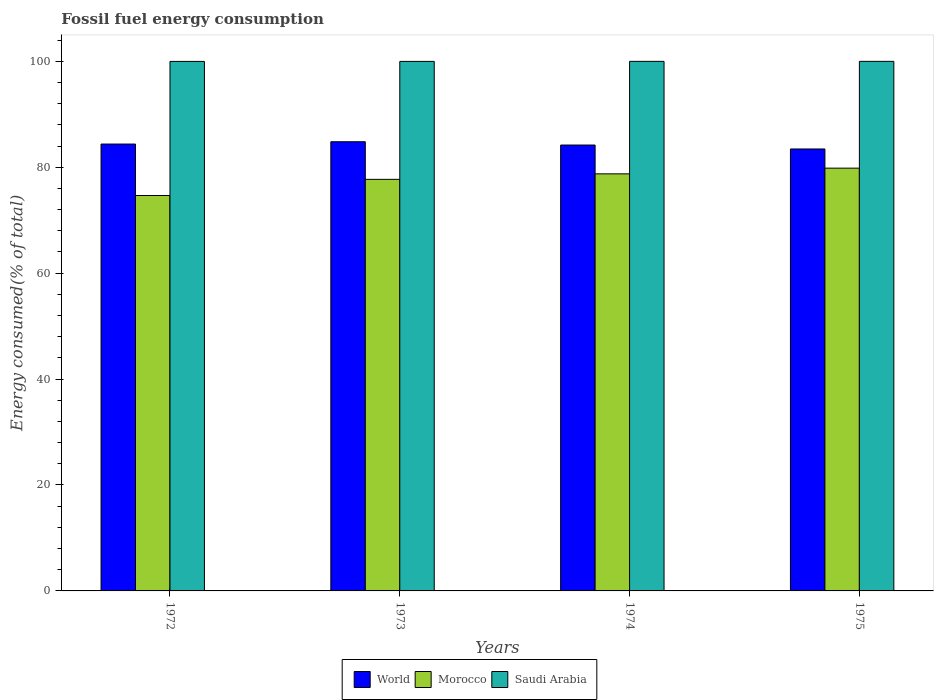Are the number of bars on each tick of the X-axis equal?
Make the answer very short. Yes. What is the label of the 1st group of bars from the left?
Offer a terse response. 1972. What is the percentage of energy consumed in World in 1975?
Your response must be concise. 83.44. Across all years, what is the maximum percentage of energy consumed in Saudi Arabia?
Keep it short and to the point. 99.99. Across all years, what is the minimum percentage of energy consumed in Saudi Arabia?
Ensure brevity in your answer.  99.98. In which year was the percentage of energy consumed in Saudi Arabia maximum?
Make the answer very short. 1975. What is the total percentage of energy consumed in Morocco in the graph?
Make the answer very short. 310.94. What is the difference between the percentage of energy consumed in Morocco in 1973 and that in 1975?
Your answer should be very brief. -2.12. What is the difference between the percentage of energy consumed in World in 1973 and the percentage of energy consumed in Saudi Arabia in 1972?
Provide a short and direct response. -15.17. What is the average percentage of energy consumed in World per year?
Provide a short and direct response. 84.2. In the year 1973, what is the difference between the percentage of energy consumed in World and percentage of energy consumed in Saudi Arabia?
Offer a terse response. -15.17. In how many years, is the percentage of energy consumed in Morocco greater than 76 %?
Offer a very short reply. 3. What is the ratio of the percentage of energy consumed in Saudi Arabia in 1972 to that in 1974?
Offer a terse response. 1. Is the percentage of energy consumed in Saudi Arabia in 1972 less than that in 1975?
Your answer should be compact. Yes. What is the difference between the highest and the second highest percentage of energy consumed in World?
Your answer should be very brief. 0.44. What is the difference between the highest and the lowest percentage of energy consumed in World?
Give a very brief answer. 1.37. What does the 3rd bar from the left in 1975 represents?
Keep it short and to the point. Saudi Arabia. What does the 1st bar from the right in 1973 represents?
Ensure brevity in your answer.  Saudi Arabia. Are all the bars in the graph horizontal?
Your response must be concise. No. How many years are there in the graph?
Offer a terse response. 4. Does the graph contain any zero values?
Your answer should be very brief. No. Where does the legend appear in the graph?
Your response must be concise. Bottom center. How are the legend labels stacked?
Offer a terse response. Horizontal. What is the title of the graph?
Provide a short and direct response. Fossil fuel energy consumption. Does "Fiji" appear as one of the legend labels in the graph?
Give a very brief answer. No. What is the label or title of the X-axis?
Ensure brevity in your answer.  Years. What is the label or title of the Y-axis?
Offer a terse response. Energy consumed(% of total). What is the Energy consumed(% of total) of World in 1972?
Offer a terse response. 84.37. What is the Energy consumed(% of total) in Morocco in 1972?
Your response must be concise. 74.66. What is the Energy consumed(% of total) in Saudi Arabia in 1972?
Offer a terse response. 99.98. What is the Energy consumed(% of total) in World in 1973?
Make the answer very short. 84.81. What is the Energy consumed(% of total) in Morocco in 1973?
Your answer should be compact. 77.71. What is the Energy consumed(% of total) of Saudi Arabia in 1973?
Provide a succinct answer. 99.98. What is the Energy consumed(% of total) of World in 1974?
Keep it short and to the point. 84.19. What is the Energy consumed(% of total) of Morocco in 1974?
Your answer should be very brief. 78.75. What is the Energy consumed(% of total) of Saudi Arabia in 1974?
Provide a succinct answer. 99.99. What is the Energy consumed(% of total) of World in 1975?
Your answer should be compact. 83.44. What is the Energy consumed(% of total) of Morocco in 1975?
Your answer should be compact. 79.83. What is the Energy consumed(% of total) of Saudi Arabia in 1975?
Give a very brief answer. 99.99. Across all years, what is the maximum Energy consumed(% of total) of World?
Keep it short and to the point. 84.81. Across all years, what is the maximum Energy consumed(% of total) in Morocco?
Ensure brevity in your answer.  79.83. Across all years, what is the maximum Energy consumed(% of total) of Saudi Arabia?
Your response must be concise. 99.99. Across all years, what is the minimum Energy consumed(% of total) in World?
Provide a succinct answer. 83.44. Across all years, what is the minimum Energy consumed(% of total) in Morocco?
Your answer should be very brief. 74.66. Across all years, what is the minimum Energy consumed(% of total) in Saudi Arabia?
Your answer should be compact. 99.98. What is the total Energy consumed(% of total) in World in the graph?
Your answer should be compact. 336.82. What is the total Energy consumed(% of total) in Morocco in the graph?
Provide a short and direct response. 310.94. What is the total Energy consumed(% of total) of Saudi Arabia in the graph?
Give a very brief answer. 399.93. What is the difference between the Energy consumed(% of total) in World in 1972 and that in 1973?
Offer a very short reply. -0.44. What is the difference between the Energy consumed(% of total) in Morocco in 1972 and that in 1973?
Ensure brevity in your answer.  -3.05. What is the difference between the Energy consumed(% of total) of Saudi Arabia in 1972 and that in 1973?
Make the answer very short. -0. What is the difference between the Energy consumed(% of total) of World in 1972 and that in 1974?
Offer a very short reply. 0.19. What is the difference between the Energy consumed(% of total) of Morocco in 1972 and that in 1974?
Offer a terse response. -4.09. What is the difference between the Energy consumed(% of total) of Saudi Arabia in 1972 and that in 1974?
Keep it short and to the point. -0.01. What is the difference between the Energy consumed(% of total) of World in 1972 and that in 1975?
Your answer should be compact. 0.93. What is the difference between the Energy consumed(% of total) in Morocco in 1972 and that in 1975?
Offer a terse response. -5.17. What is the difference between the Energy consumed(% of total) in Saudi Arabia in 1972 and that in 1975?
Offer a very short reply. -0.01. What is the difference between the Energy consumed(% of total) of World in 1973 and that in 1974?
Offer a very short reply. 0.62. What is the difference between the Energy consumed(% of total) of Morocco in 1973 and that in 1974?
Offer a very short reply. -1.04. What is the difference between the Energy consumed(% of total) in Saudi Arabia in 1973 and that in 1974?
Your response must be concise. -0.01. What is the difference between the Energy consumed(% of total) of World in 1973 and that in 1975?
Give a very brief answer. 1.37. What is the difference between the Energy consumed(% of total) in Morocco in 1973 and that in 1975?
Offer a terse response. -2.12. What is the difference between the Energy consumed(% of total) in Saudi Arabia in 1973 and that in 1975?
Offer a very short reply. -0.01. What is the difference between the Energy consumed(% of total) of World in 1974 and that in 1975?
Ensure brevity in your answer.  0.74. What is the difference between the Energy consumed(% of total) in Morocco in 1974 and that in 1975?
Make the answer very short. -1.08. What is the difference between the Energy consumed(% of total) in Saudi Arabia in 1974 and that in 1975?
Your answer should be very brief. -0. What is the difference between the Energy consumed(% of total) of World in 1972 and the Energy consumed(% of total) of Morocco in 1973?
Ensure brevity in your answer.  6.66. What is the difference between the Energy consumed(% of total) in World in 1972 and the Energy consumed(% of total) in Saudi Arabia in 1973?
Provide a short and direct response. -15.61. What is the difference between the Energy consumed(% of total) in Morocco in 1972 and the Energy consumed(% of total) in Saudi Arabia in 1973?
Keep it short and to the point. -25.32. What is the difference between the Energy consumed(% of total) in World in 1972 and the Energy consumed(% of total) in Morocco in 1974?
Provide a succinct answer. 5.63. What is the difference between the Energy consumed(% of total) of World in 1972 and the Energy consumed(% of total) of Saudi Arabia in 1974?
Your answer should be very brief. -15.61. What is the difference between the Energy consumed(% of total) in Morocco in 1972 and the Energy consumed(% of total) in Saudi Arabia in 1974?
Your response must be concise. -25.33. What is the difference between the Energy consumed(% of total) of World in 1972 and the Energy consumed(% of total) of Morocco in 1975?
Ensure brevity in your answer.  4.55. What is the difference between the Energy consumed(% of total) in World in 1972 and the Energy consumed(% of total) in Saudi Arabia in 1975?
Your answer should be compact. -15.61. What is the difference between the Energy consumed(% of total) in Morocco in 1972 and the Energy consumed(% of total) in Saudi Arabia in 1975?
Ensure brevity in your answer.  -25.33. What is the difference between the Energy consumed(% of total) in World in 1973 and the Energy consumed(% of total) in Morocco in 1974?
Provide a short and direct response. 6.06. What is the difference between the Energy consumed(% of total) of World in 1973 and the Energy consumed(% of total) of Saudi Arabia in 1974?
Offer a very short reply. -15.18. What is the difference between the Energy consumed(% of total) in Morocco in 1973 and the Energy consumed(% of total) in Saudi Arabia in 1974?
Your answer should be compact. -22.28. What is the difference between the Energy consumed(% of total) of World in 1973 and the Energy consumed(% of total) of Morocco in 1975?
Make the answer very short. 4.98. What is the difference between the Energy consumed(% of total) of World in 1973 and the Energy consumed(% of total) of Saudi Arabia in 1975?
Provide a succinct answer. -15.18. What is the difference between the Energy consumed(% of total) in Morocco in 1973 and the Energy consumed(% of total) in Saudi Arabia in 1975?
Your response must be concise. -22.28. What is the difference between the Energy consumed(% of total) of World in 1974 and the Energy consumed(% of total) of Morocco in 1975?
Your answer should be compact. 4.36. What is the difference between the Energy consumed(% of total) of World in 1974 and the Energy consumed(% of total) of Saudi Arabia in 1975?
Offer a terse response. -15.8. What is the difference between the Energy consumed(% of total) in Morocco in 1974 and the Energy consumed(% of total) in Saudi Arabia in 1975?
Your answer should be very brief. -21.24. What is the average Energy consumed(% of total) in World per year?
Ensure brevity in your answer.  84.2. What is the average Energy consumed(% of total) in Morocco per year?
Your answer should be very brief. 77.74. What is the average Energy consumed(% of total) of Saudi Arabia per year?
Provide a short and direct response. 99.98. In the year 1972, what is the difference between the Energy consumed(% of total) in World and Energy consumed(% of total) in Morocco?
Give a very brief answer. 9.71. In the year 1972, what is the difference between the Energy consumed(% of total) of World and Energy consumed(% of total) of Saudi Arabia?
Your response must be concise. -15.6. In the year 1972, what is the difference between the Energy consumed(% of total) in Morocco and Energy consumed(% of total) in Saudi Arabia?
Your answer should be compact. -25.32. In the year 1973, what is the difference between the Energy consumed(% of total) in World and Energy consumed(% of total) in Morocco?
Your answer should be compact. 7.1. In the year 1973, what is the difference between the Energy consumed(% of total) in World and Energy consumed(% of total) in Saudi Arabia?
Make the answer very short. -15.17. In the year 1973, what is the difference between the Energy consumed(% of total) of Morocco and Energy consumed(% of total) of Saudi Arabia?
Your answer should be compact. -22.27. In the year 1974, what is the difference between the Energy consumed(% of total) in World and Energy consumed(% of total) in Morocco?
Provide a short and direct response. 5.44. In the year 1974, what is the difference between the Energy consumed(% of total) in World and Energy consumed(% of total) in Saudi Arabia?
Give a very brief answer. -15.8. In the year 1974, what is the difference between the Energy consumed(% of total) of Morocco and Energy consumed(% of total) of Saudi Arabia?
Make the answer very short. -21.24. In the year 1975, what is the difference between the Energy consumed(% of total) of World and Energy consumed(% of total) of Morocco?
Provide a short and direct response. 3.62. In the year 1975, what is the difference between the Energy consumed(% of total) of World and Energy consumed(% of total) of Saudi Arabia?
Your answer should be compact. -16.54. In the year 1975, what is the difference between the Energy consumed(% of total) in Morocco and Energy consumed(% of total) in Saudi Arabia?
Ensure brevity in your answer.  -20.16. What is the ratio of the Energy consumed(% of total) in Morocco in 1972 to that in 1973?
Make the answer very short. 0.96. What is the ratio of the Energy consumed(% of total) of Saudi Arabia in 1972 to that in 1973?
Offer a terse response. 1. What is the ratio of the Energy consumed(% of total) of World in 1972 to that in 1974?
Offer a terse response. 1. What is the ratio of the Energy consumed(% of total) of Morocco in 1972 to that in 1974?
Make the answer very short. 0.95. What is the ratio of the Energy consumed(% of total) in World in 1972 to that in 1975?
Your answer should be compact. 1.01. What is the ratio of the Energy consumed(% of total) of Morocco in 1972 to that in 1975?
Keep it short and to the point. 0.94. What is the ratio of the Energy consumed(% of total) of World in 1973 to that in 1974?
Offer a very short reply. 1.01. What is the ratio of the Energy consumed(% of total) of Saudi Arabia in 1973 to that in 1974?
Your answer should be very brief. 1. What is the ratio of the Energy consumed(% of total) in World in 1973 to that in 1975?
Offer a terse response. 1.02. What is the ratio of the Energy consumed(% of total) of Morocco in 1973 to that in 1975?
Your answer should be very brief. 0.97. What is the ratio of the Energy consumed(% of total) of World in 1974 to that in 1975?
Offer a terse response. 1.01. What is the ratio of the Energy consumed(% of total) in Morocco in 1974 to that in 1975?
Keep it short and to the point. 0.99. What is the difference between the highest and the second highest Energy consumed(% of total) of World?
Your answer should be compact. 0.44. What is the difference between the highest and the second highest Energy consumed(% of total) in Morocco?
Your answer should be very brief. 1.08. What is the difference between the highest and the second highest Energy consumed(% of total) in Saudi Arabia?
Give a very brief answer. 0. What is the difference between the highest and the lowest Energy consumed(% of total) of World?
Provide a short and direct response. 1.37. What is the difference between the highest and the lowest Energy consumed(% of total) of Morocco?
Your response must be concise. 5.17. What is the difference between the highest and the lowest Energy consumed(% of total) of Saudi Arabia?
Give a very brief answer. 0.01. 